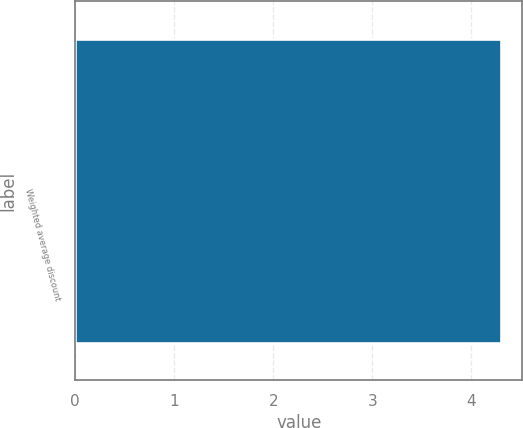<chart> <loc_0><loc_0><loc_500><loc_500><bar_chart><fcel>Weighted average discount<nl><fcel>4.3<nl></chart> 